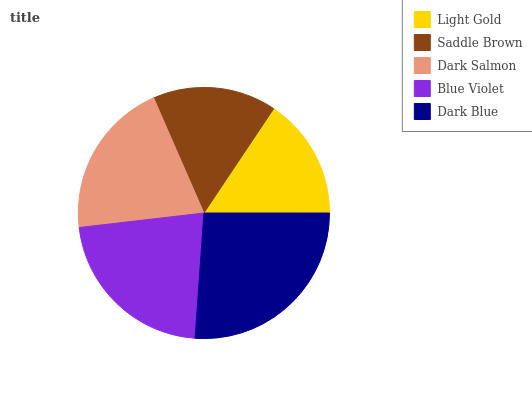Is Light Gold the minimum?
Answer yes or no. Yes. Is Dark Blue the maximum?
Answer yes or no. Yes. Is Saddle Brown the minimum?
Answer yes or no. No. Is Saddle Brown the maximum?
Answer yes or no. No. Is Saddle Brown greater than Light Gold?
Answer yes or no. Yes. Is Light Gold less than Saddle Brown?
Answer yes or no. Yes. Is Light Gold greater than Saddle Brown?
Answer yes or no. No. Is Saddle Brown less than Light Gold?
Answer yes or no. No. Is Dark Salmon the high median?
Answer yes or no. Yes. Is Dark Salmon the low median?
Answer yes or no. Yes. Is Dark Blue the high median?
Answer yes or no. No. Is Light Gold the low median?
Answer yes or no. No. 